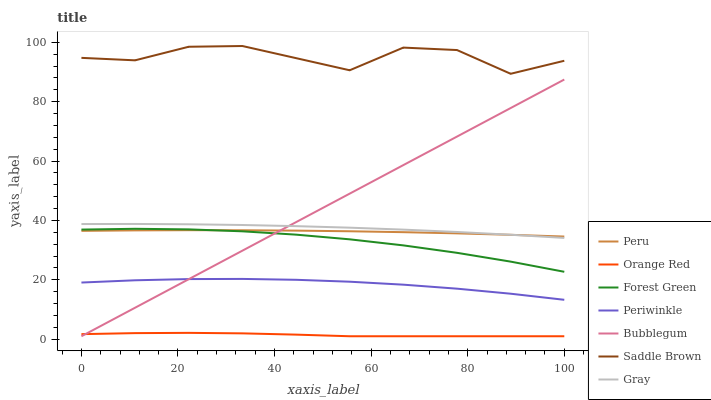Does Orange Red have the minimum area under the curve?
Answer yes or no. Yes. Does Saddle Brown have the maximum area under the curve?
Answer yes or no. Yes. Does Bubblegum have the minimum area under the curve?
Answer yes or no. No. Does Bubblegum have the maximum area under the curve?
Answer yes or no. No. Is Bubblegum the smoothest?
Answer yes or no. Yes. Is Saddle Brown the roughest?
Answer yes or no. Yes. Is Saddle Brown the smoothest?
Answer yes or no. No. Is Bubblegum the roughest?
Answer yes or no. No. Does Bubblegum have the lowest value?
Answer yes or no. Yes. Does Saddle Brown have the lowest value?
Answer yes or no. No. Does Saddle Brown have the highest value?
Answer yes or no. Yes. Does Bubblegum have the highest value?
Answer yes or no. No. Is Periwinkle less than Forest Green?
Answer yes or no. Yes. Is Saddle Brown greater than Gray?
Answer yes or no. Yes. Does Bubblegum intersect Gray?
Answer yes or no. Yes. Is Bubblegum less than Gray?
Answer yes or no. No. Is Bubblegum greater than Gray?
Answer yes or no. No. Does Periwinkle intersect Forest Green?
Answer yes or no. No. 